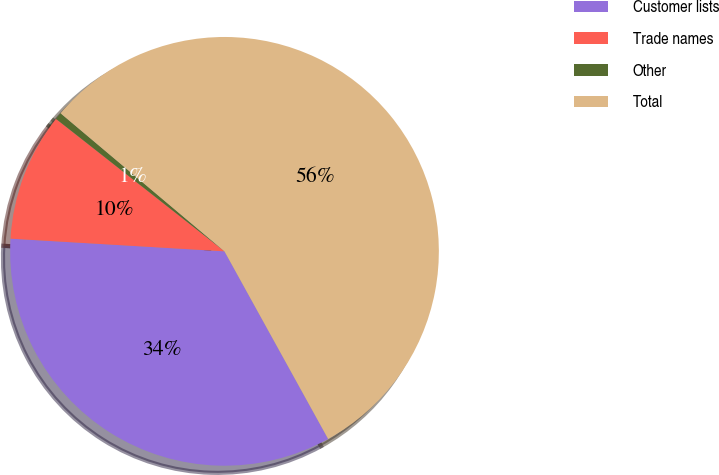Convert chart to OTSL. <chart><loc_0><loc_0><loc_500><loc_500><pie_chart><fcel>Customer lists<fcel>Trade names<fcel>Other<fcel>Total<nl><fcel>33.98%<fcel>9.66%<fcel>0.54%<fcel>55.83%<nl></chart> 